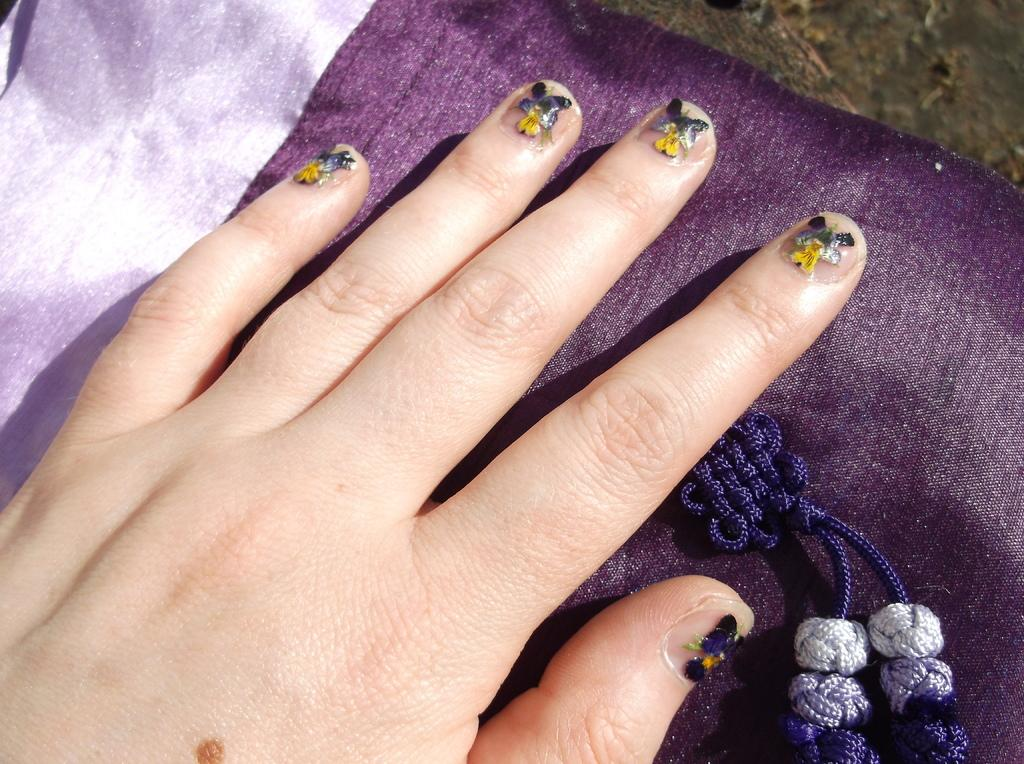What part of a person's body is visible in the image? The image contains the palm of a person. What is a noticeable feature of the person's nails in the image? The person's nails have nail art. What is the palm placed on in the image? The palm is placed on a cloth. What type of ant can be seen crawling on the sky in the image? There is no ant or sky present in the image; it features the palm of a person with nail art on a cloth. 